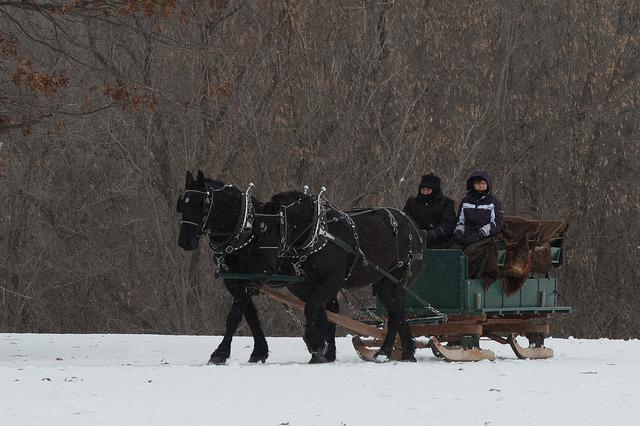How many people can you see?
Give a very brief answer. 2. How many horses are in the photo?
Give a very brief answer. 2. How many pizzas are on the table?
Give a very brief answer. 0. 